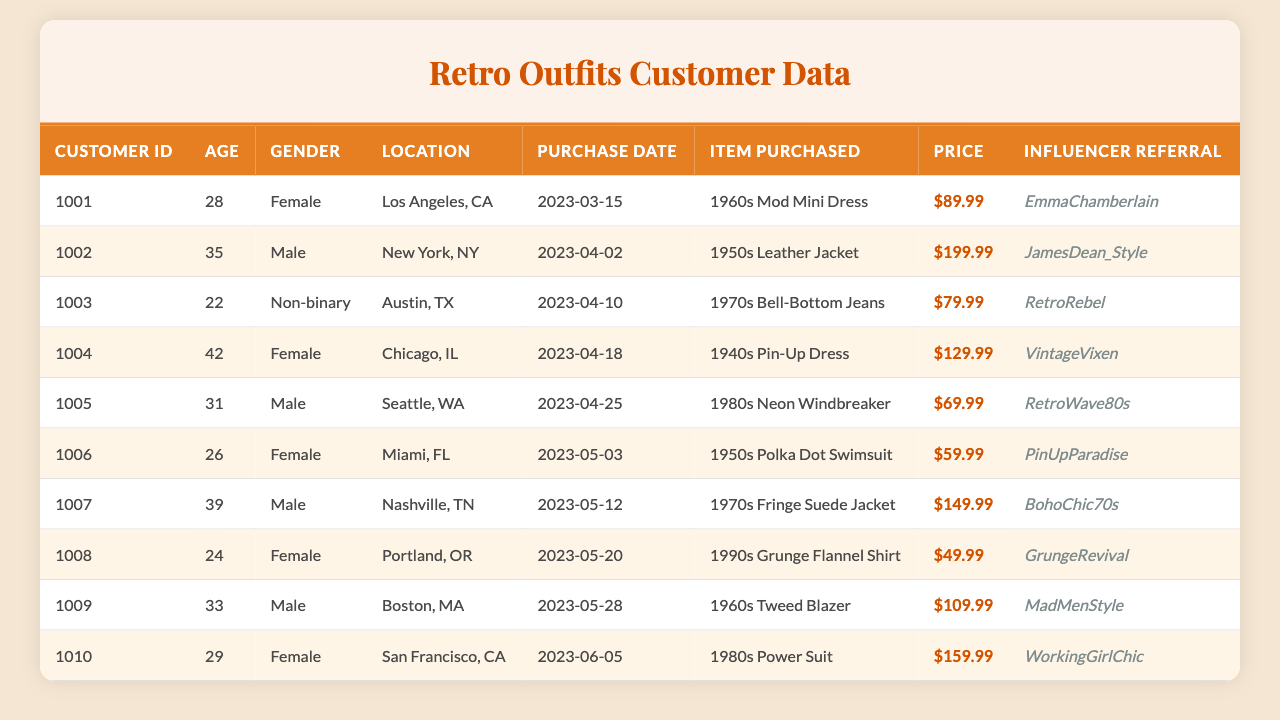What is the age of the customer who purchased the "1980s Power Suit"? The customer who purchased the "1980s Power Suit" is identified by customer ID 1010, and their age is listed as 29.
Answer: 29 Which item was purchased by the youngest customer? The youngest customer is identified by customer ID 1003, who is 22 years old and purchased "1970s Bell-Bottom Jeans".
Answer: 1970s Bell-Bottom Jeans How many male customers made a purchase? Counting the rows in the table, there are four male customers identified by the gender "Male," specifically customer IDs 1002, 1005, 1007, and 1009.
Answer: 4 What is the total amount spent on items purchased by female customers? Both female customers bought items priced at $89.99 (customer 1001) and $129.99 (customer 1004) for a total of $219.98. The sum is $89.99 + $129.99 = $219.98.
Answer: $219.98 Which influencer had the highest referral prices associated with purchases? Analyzing the prices associated with influencer referrals, JamesDean_Style includes a leather jacket at $199.99, which is the highest among all influencers.
Answer: JamesDean_Style Did any customer purchase an item for less than $50? Checking the table, the item "1990s Grunge Flannel Shirt" purchased by customer 1008 is priced at $49.99, confirming that at least one item falls below $50.
Answer: Yes Which item purchased has the highest price, and who bought it? The highest-priced item is the "1950s Leather Jacket" purchased by customer ID 1002 for $199.99.
Answer: 1950s Leather Jacket, customer 1002 What is the average age of customers that purchased items associated with "EmmaChamberlain"? EmmaChamberlain referred one customer, age 28 (customer 1001). Therefore, the average age is simply 28 because it's based on one data point.
Answer: 28 What percentage of total purchases were made by customers in their 30s? There are three customers in their 30s (1002, 1005, 1009) out of a total of ten customers. The percentage is (3/10)*100 = 30%.
Answer: 30% How many different item styles are represented in the purchases? Counting distinct item names in the table, we find ten different items representing distinct styles: "1960s Mod Mini Dress," "1950s Leather Jacket," "1970s Bell-Bottom Jeans," "1940s Pin-Up Dress," "1980s Neon Windbreaker," "1950s Polka Dot Swimsuit," "1970s Fringe Suede Jacket," "1990s Grunge Flannel Shirt," "1960s Tweed Blazer," and "1980s Power Suit," totaling 10 items.
Answer: 10 